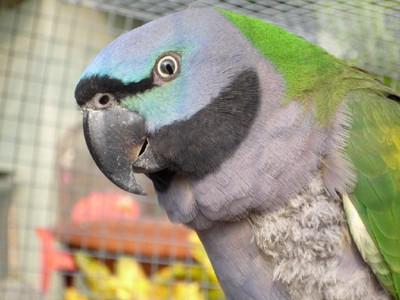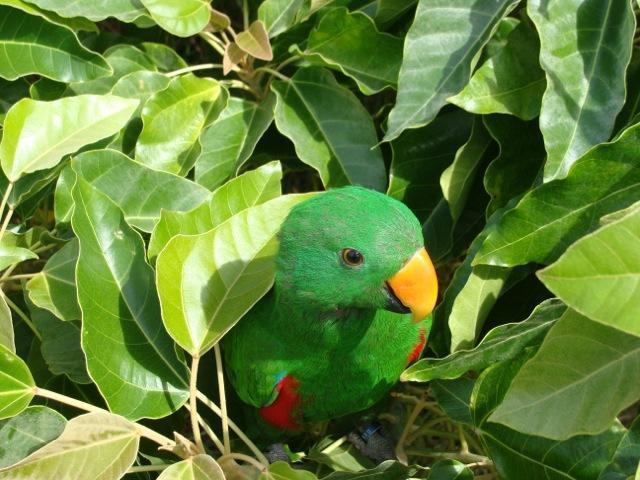The first image is the image on the left, the second image is the image on the right. For the images shown, is this caption "There is at least one image where there is a cage." true? Answer yes or no. Yes. The first image is the image on the left, the second image is the image on the right. Examine the images to the left and right. Is the description "In one image there are 3 parrots standing on a branch" accurate? Answer yes or no. No. 